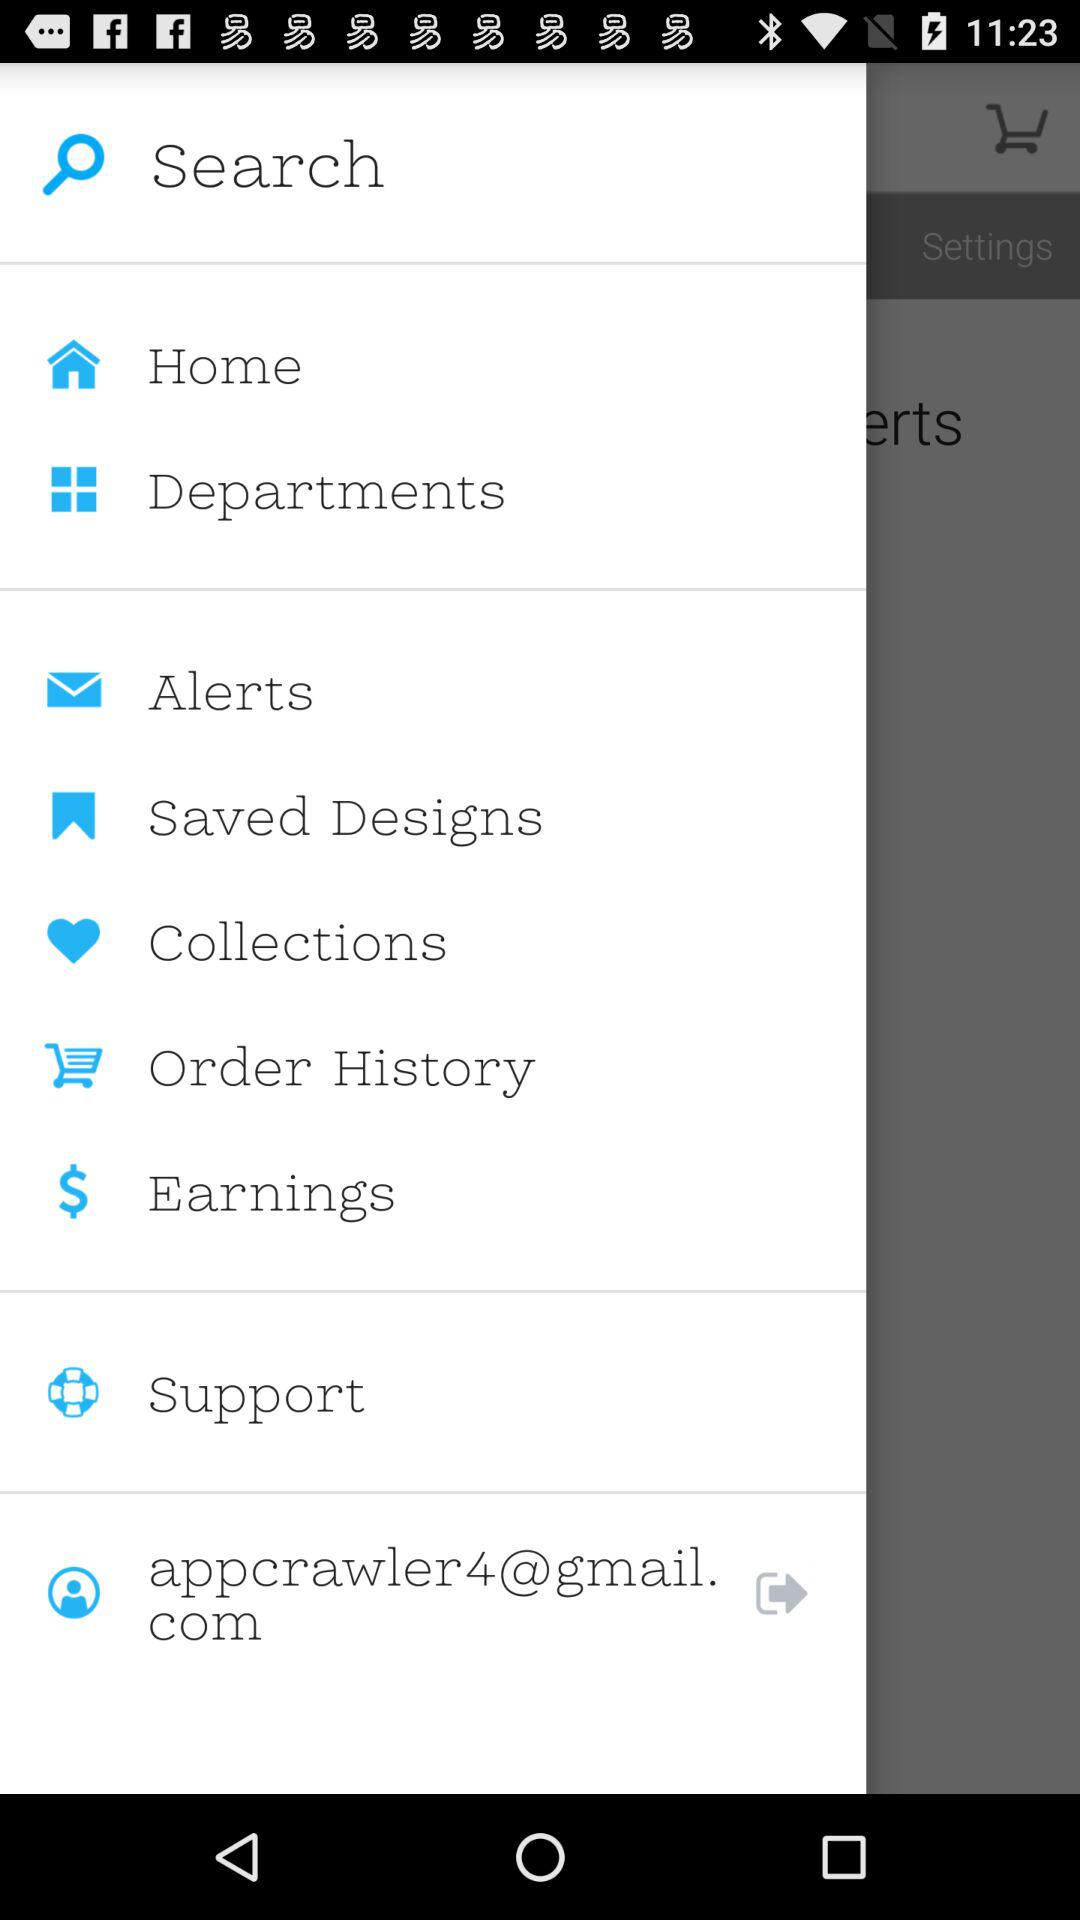How many saved designs are there?
When the provided information is insufficient, respond with <no answer>. <no answer> 